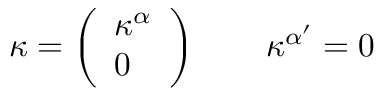<formula> <loc_0><loc_0><loc_500><loc_500>\kappa = \left ( \begin{array} { l } { { \kappa ^ { \alpha } } } \\ { 0 } \end{array} \right ) \quad \kappa ^ { \alpha ^ { \prime } } = 0</formula> 